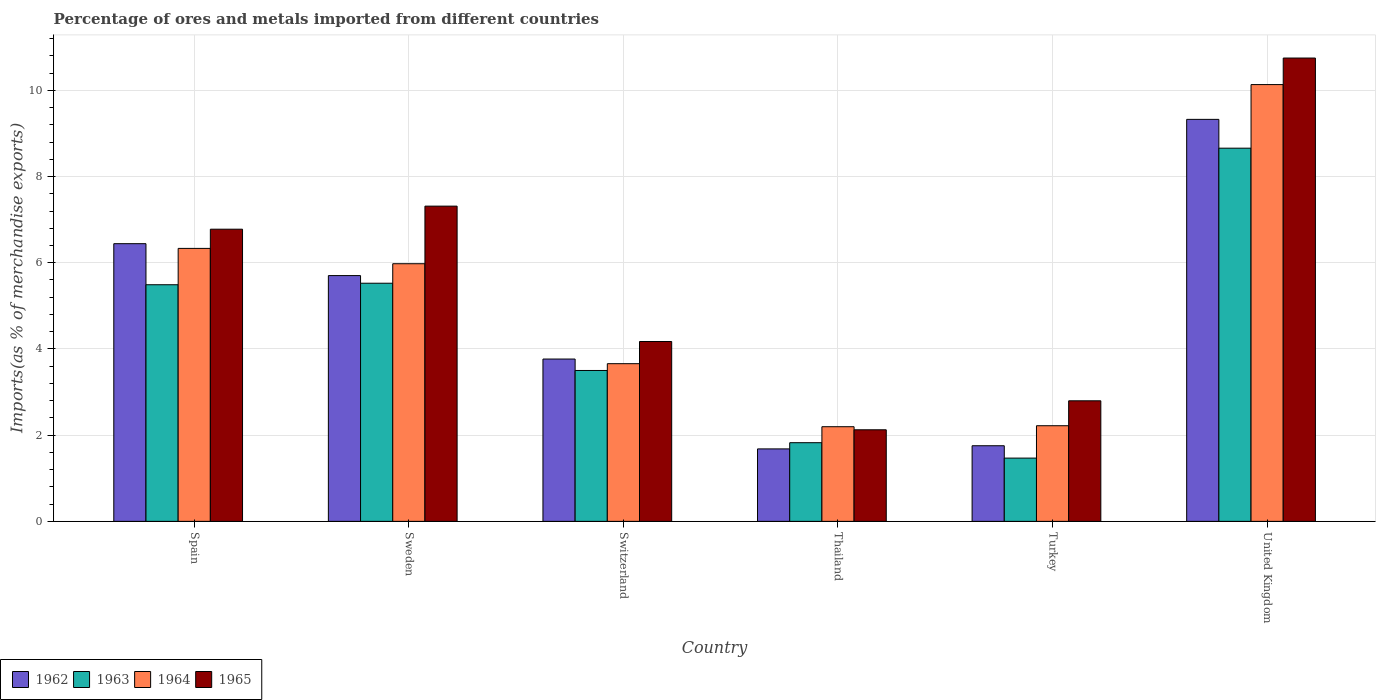How many different coloured bars are there?
Ensure brevity in your answer.  4. Are the number of bars per tick equal to the number of legend labels?
Give a very brief answer. Yes. Are the number of bars on each tick of the X-axis equal?
Your answer should be very brief. Yes. In how many cases, is the number of bars for a given country not equal to the number of legend labels?
Your answer should be compact. 0. What is the percentage of imports to different countries in 1962 in Spain?
Provide a succinct answer. 6.44. Across all countries, what is the maximum percentage of imports to different countries in 1962?
Your answer should be compact. 9.33. Across all countries, what is the minimum percentage of imports to different countries in 1965?
Provide a short and direct response. 2.12. In which country was the percentage of imports to different countries in 1962 minimum?
Your answer should be compact. Thailand. What is the total percentage of imports to different countries in 1964 in the graph?
Make the answer very short. 30.52. What is the difference between the percentage of imports to different countries in 1965 in Spain and that in Turkey?
Offer a terse response. 3.98. What is the difference between the percentage of imports to different countries in 1962 in Sweden and the percentage of imports to different countries in 1964 in Spain?
Offer a very short reply. -0.63. What is the average percentage of imports to different countries in 1964 per country?
Ensure brevity in your answer.  5.09. What is the difference between the percentage of imports to different countries of/in 1963 and percentage of imports to different countries of/in 1964 in Switzerland?
Offer a very short reply. -0.16. What is the ratio of the percentage of imports to different countries in 1962 in Sweden to that in United Kingdom?
Give a very brief answer. 0.61. Is the percentage of imports to different countries in 1965 in Sweden less than that in United Kingdom?
Offer a terse response. Yes. What is the difference between the highest and the second highest percentage of imports to different countries in 1963?
Your response must be concise. 3.17. What is the difference between the highest and the lowest percentage of imports to different countries in 1965?
Keep it short and to the point. 8.62. In how many countries, is the percentage of imports to different countries in 1963 greater than the average percentage of imports to different countries in 1963 taken over all countries?
Keep it short and to the point. 3. Is the sum of the percentage of imports to different countries in 1963 in Sweden and United Kingdom greater than the maximum percentage of imports to different countries in 1965 across all countries?
Your answer should be very brief. Yes. What does the 4th bar from the left in Thailand represents?
Keep it short and to the point. 1965. What does the 2nd bar from the right in Thailand represents?
Offer a terse response. 1964. How many bars are there?
Make the answer very short. 24. Are all the bars in the graph horizontal?
Your answer should be very brief. No. How many countries are there in the graph?
Your answer should be very brief. 6. Are the values on the major ticks of Y-axis written in scientific E-notation?
Make the answer very short. No. Where does the legend appear in the graph?
Provide a short and direct response. Bottom left. What is the title of the graph?
Offer a terse response. Percentage of ores and metals imported from different countries. Does "1977" appear as one of the legend labels in the graph?
Provide a short and direct response. No. What is the label or title of the Y-axis?
Your answer should be compact. Imports(as % of merchandise exports). What is the Imports(as % of merchandise exports) of 1962 in Spain?
Offer a very short reply. 6.44. What is the Imports(as % of merchandise exports) of 1963 in Spain?
Give a very brief answer. 5.49. What is the Imports(as % of merchandise exports) of 1964 in Spain?
Your answer should be compact. 6.33. What is the Imports(as % of merchandise exports) in 1965 in Spain?
Provide a short and direct response. 6.78. What is the Imports(as % of merchandise exports) of 1962 in Sweden?
Keep it short and to the point. 5.7. What is the Imports(as % of merchandise exports) in 1963 in Sweden?
Ensure brevity in your answer.  5.52. What is the Imports(as % of merchandise exports) in 1964 in Sweden?
Your answer should be very brief. 5.98. What is the Imports(as % of merchandise exports) of 1965 in Sweden?
Provide a short and direct response. 7.31. What is the Imports(as % of merchandise exports) in 1962 in Switzerland?
Your answer should be very brief. 3.77. What is the Imports(as % of merchandise exports) in 1963 in Switzerland?
Your answer should be very brief. 3.5. What is the Imports(as % of merchandise exports) of 1964 in Switzerland?
Keep it short and to the point. 3.66. What is the Imports(as % of merchandise exports) in 1965 in Switzerland?
Provide a short and direct response. 4.17. What is the Imports(as % of merchandise exports) of 1962 in Thailand?
Ensure brevity in your answer.  1.68. What is the Imports(as % of merchandise exports) of 1963 in Thailand?
Offer a terse response. 1.83. What is the Imports(as % of merchandise exports) in 1964 in Thailand?
Your answer should be compact. 2.2. What is the Imports(as % of merchandise exports) of 1965 in Thailand?
Make the answer very short. 2.12. What is the Imports(as % of merchandise exports) in 1962 in Turkey?
Offer a terse response. 1.75. What is the Imports(as % of merchandise exports) of 1963 in Turkey?
Ensure brevity in your answer.  1.47. What is the Imports(as % of merchandise exports) in 1964 in Turkey?
Provide a short and direct response. 2.22. What is the Imports(as % of merchandise exports) of 1965 in Turkey?
Provide a succinct answer. 2.8. What is the Imports(as % of merchandise exports) of 1962 in United Kingdom?
Make the answer very short. 9.33. What is the Imports(as % of merchandise exports) in 1963 in United Kingdom?
Keep it short and to the point. 8.66. What is the Imports(as % of merchandise exports) in 1964 in United Kingdom?
Your answer should be compact. 10.13. What is the Imports(as % of merchandise exports) in 1965 in United Kingdom?
Your answer should be very brief. 10.75. Across all countries, what is the maximum Imports(as % of merchandise exports) of 1962?
Make the answer very short. 9.33. Across all countries, what is the maximum Imports(as % of merchandise exports) of 1963?
Provide a succinct answer. 8.66. Across all countries, what is the maximum Imports(as % of merchandise exports) of 1964?
Your response must be concise. 10.13. Across all countries, what is the maximum Imports(as % of merchandise exports) in 1965?
Offer a very short reply. 10.75. Across all countries, what is the minimum Imports(as % of merchandise exports) in 1962?
Your answer should be very brief. 1.68. Across all countries, what is the minimum Imports(as % of merchandise exports) of 1963?
Offer a very short reply. 1.47. Across all countries, what is the minimum Imports(as % of merchandise exports) in 1964?
Provide a succinct answer. 2.2. Across all countries, what is the minimum Imports(as % of merchandise exports) in 1965?
Keep it short and to the point. 2.12. What is the total Imports(as % of merchandise exports) of 1962 in the graph?
Provide a succinct answer. 28.67. What is the total Imports(as % of merchandise exports) in 1963 in the graph?
Offer a terse response. 26.47. What is the total Imports(as % of merchandise exports) of 1964 in the graph?
Offer a terse response. 30.52. What is the total Imports(as % of merchandise exports) of 1965 in the graph?
Ensure brevity in your answer.  33.94. What is the difference between the Imports(as % of merchandise exports) in 1962 in Spain and that in Sweden?
Give a very brief answer. 0.74. What is the difference between the Imports(as % of merchandise exports) of 1963 in Spain and that in Sweden?
Your answer should be compact. -0.04. What is the difference between the Imports(as % of merchandise exports) of 1964 in Spain and that in Sweden?
Ensure brevity in your answer.  0.36. What is the difference between the Imports(as % of merchandise exports) in 1965 in Spain and that in Sweden?
Ensure brevity in your answer.  -0.54. What is the difference between the Imports(as % of merchandise exports) of 1962 in Spain and that in Switzerland?
Offer a very short reply. 2.68. What is the difference between the Imports(as % of merchandise exports) of 1963 in Spain and that in Switzerland?
Your response must be concise. 1.99. What is the difference between the Imports(as % of merchandise exports) in 1964 in Spain and that in Switzerland?
Your answer should be very brief. 2.67. What is the difference between the Imports(as % of merchandise exports) of 1965 in Spain and that in Switzerland?
Make the answer very short. 2.61. What is the difference between the Imports(as % of merchandise exports) of 1962 in Spain and that in Thailand?
Ensure brevity in your answer.  4.76. What is the difference between the Imports(as % of merchandise exports) of 1963 in Spain and that in Thailand?
Keep it short and to the point. 3.66. What is the difference between the Imports(as % of merchandise exports) in 1964 in Spain and that in Thailand?
Your answer should be very brief. 4.14. What is the difference between the Imports(as % of merchandise exports) in 1965 in Spain and that in Thailand?
Ensure brevity in your answer.  4.65. What is the difference between the Imports(as % of merchandise exports) in 1962 in Spain and that in Turkey?
Your answer should be very brief. 4.69. What is the difference between the Imports(as % of merchandise exports) in 1963 in Spain and that in Turkey?
Keep it short and to the point. 4.02. What is the difference between the Imports(as % of merchandise exports) in 1964 in Spain and that in Turkey?
Keep it short and to the point. 4.11. What is the difference between the Imports(as % of merchandise exports) of 1965 in Spain and that in Turkey?
Your answer should be compact. 3.98. What is the difference between the Imports(as % of merchandise exports) in 1962 in Spain and that in United Kingdom?
Give a very brief answer. -2.88. What is the difference between the Imports(as % of merchandise exports) of 1963 in Spain and that in United Kingdom?
Provide a succinct answer. -3.17. What is the difference between the Imports(as % of merchandise exports) of 1964 in Spain and that in United Kingdom?
Your response must be concise. -3.8. What is the difference between the Imports(as % of merchandise exports) in 1965 in Spain and that in United Kingdom?
Give a very brief answer. -3.97. What is the difference between the Imports(as % of merchandise exports) of 1962 in Sweden and that in Switzerland?
Offer a very short reply. 1.94. What is the difference between the Imports(as % of merchandise exports) in 1963 in Sweden and that in Switzerland?
Keep it short and to the point. 2.02. What is the difference between the Imports(as % of merchandise exports) of 1964 in Sweden and that in Switzerland?
Offer a terse response. 2.32. What is the difference between the Imports(as % of merchandise exports) in 1965 in Sweden and that in Switzerland?
Offer a very short reply. 3.14. What is the difference between the Imports(as % of merchandise exports) of 1962 in Sweden and that in Thailand?
Your response must be concise. 4.02. What is the difference between the Imports(as % of merchandise exports) in 1963 in Sweden and that in Thailand?
Provide a succinct answer. 3.7. What is the difference between the Imports(as % of merchandise exports) in 1964 in Sweden and that in Thailand?
Offer a very short reply. 3.78. What is the difference between the Imports(as % of merchandise exports) of 1965 in Sweden and that in Thailand?
Give a very brief answer. 5.19. What is the difference between the Imports(as % of merchandise exports) of 1962 in Sweden and that in Turkey?
Keep it short and to the point. 3.95. What is the difference between the Imports(as % of merchandise exports) of 1963 in Sweden and that in Turkey?
Your answer should be compact. 4.06. What is the difference between the Imports(as % of merchandise exports) of 1964 in Sweden and that in Turkey?
Make the answer very short. 3.76. What is the difference between the Imports(as % of merchandise exports) of 1965 in Sweden and that in Turkey?
Your answer should be very brief. 4.52. What is the difference between the Imports(as % of merchandise exports) in 1962 in Sweden and that in United Kingdom?
Your answer should be compact. -3.62. What is the difference between the Imports(as % of merchandise exports) of 1963 in Sweden and that in United Kingdom?
Give a very brief answer. -3.13. What is the difference between the Imports(as % of merchandise exports) of 1964 in Sweden and that in United Kingdom?
Your answer should be compact. -4.16. What is the difference between the Imports(as % of merchandise exports) in 1965 in Sweden and that in United Kingdom?
Your response must be concise. -3.44. What is the difference between the Imports(as % of merchandise exports) in 1962 in Switzerland and that in Thailand?
Make the answer very short. 2.08. What is the difference between the Imports(as % of merchandise exports) in 1963 in Switzerland and that in Thailand?
Ensure brevity in your answer.  1.68. What is the difference between the Imports(as % of merchandise exports) in 1964 in Switzerland and that in Thailand?
Offer a very short reply. 1.46. What is the difference between the Imports(as % of merchandise exports) of 1965 in Switzerland and that in Thailand?
Give a very brief answer. 2.05. What is the difference between the Imports(as % of merchandise exports) of 1962 in Switzerland and that in Turkey?
Keep it short and to the point. 2.01. What is the difference between the Imports(as % of merchandise exports) of 1963 in Switzerland and that in Turkey?
Offer a very short reply. 2.03. What is the difference between the Imports(as % of merchandise exports) in 1964 in Switzerland and that in Turkey?
Provide a short and direct response. 1.44. What is the difference between the Imports(as % of merchandise exports) of 1965 in Switzerland and that in Turkey?
Provide a short and direct response. 1.38. What is the difference between the Imports(as % of merchandise exports) of 1962 in Switzerland and that in United Kingdom?
Keep it short and to the point. -5.56. What is the difference between the Imports(as % of merchandise exports) of 1963 in Switzerland and that in United Kingdom?
Ensure brevity in your answer.  -5.16. What is the difference between the Imports(as % of merchandise exports) of 1964 in Switzerland and that in United Kingdom?
Keep it short and to the point. -6.48. What is the difference between the Imports(as % of merchandise exports) of 1965 in Switzerland and that in United Kingdom?
Your answer should be very brief. -6.58. What is the difference between the Imports(as % of merchandise exports) in 1962 in Thailand and that in Turkey?
Offer a terse response. -0.07. What is the difference between the Imports(as % of merchandise exports) of 1963 in Thailand and that in Turkey?
Give a very brief answer. 0.36. What is the difference between the Imports(as % of merchandise exports) in 1964 in Thailand and that in Turkey?
Give a very brief answer. -0.02. What is the difference between the Imports(as % of merchandise exports) of 1965 in Thailand and that in Turkey?
Your response must be concise. -0.67. What is the difference between the Imports(as % of merchandise exports) of 1962 in Thailand and that in United Kingdom?
Keep it short and to the point. -7.65. What is the difference between the Imports(as % of merchandise exports) of 1963 in Thailand and that in United Kingdom?
Your response must be concise. -6.83. What is the difference between the Imports(as % of merchandise exports) in 1964 in Thailand and that in United Kingdom?
Offer a terse response. -7.94. What is the difference between the Imports(as % of merchandise exports) in 1965 in Thailand and that in United Kingdom?
Offer a terse response. -8.62. What is the difference between the Imports(as % of merchandise exports) in 1962 in Turkey and that in United Kingdom?
Your response must be concise. -7.57. What is the difference between the Imports(as % of merchandise exports) in 1963 in Turkey and that in United Kingdom?
Keep it short and to the point. -7.19. What is the difference between the Imports(as % of merchandise exports) of 1964 in Turkey and that in United Kingdom?
Your answer should be very brief. -7.91. What is the difference between the Imports(as % of merchandise exports) of 1965 in Turkey and that in United Kingdom?
Your answer should be very brief. -7.95. What is the difference between the Imports(as % of merchandise exports) of 1962 in Spain and the Imports(as % of merchandise exports) of 1963 in Sweden?
Give a very brief answer. 0.92. What is the difference between the Imports(as % of merchandise exports) in 1962 in Spain and the Imports(as % of merchandise exports) in 1964 in Sweden?
Your answer should be compact. 0.47. What is the difference between the Imports(as % of merchandise exports) in 1962 in Spain and the Imports(as % of merchandise exports) in 1965 in Sweden?
Your answer should be very brief. -0.87. What is the difference between the Imports(as % of merchandise exports) of 1963 in Spain and the Imports(as % of merchandise exports) of 1964 in Sweden?
Your answer should be compact. -0.49. What is the difference between the Imports(as % of merchandise exports) in 1963 in Spain and the Imports(as % of merchandise exports) in 1965 in Sweden?
Offer a terse response. -1.82. What is the difference between the Imports(as % of merchandise exports) in 1964 in Spain and the Imports(as % of merchandise exports) in 1965 in Sweden?
Ensure brevity in your answer.  -0.98. What is the difference between the Imports(as % of merchandise exports) of 1962 in Spain and the Imports(as % of merchandise exports) of 1963 in Switzerland?
Provide a succinct answer. 2.94. What is the difference between the Imports(as % of merchandise exports) of 1962 in Spain and the Imports(as % of merchandise exports) of 1964 in Switzerland?
Ensure brevity in your answer.  2.78. What is the difference between the Imports(as % of merchandise exports) of 1962 in Spain and the Imports(as % of merchandise exports) of 1965 in Switzerland?
Your response must be concise. 2.27. What is the difference between the Imports(as % of merchandise exports) in 1963 in Spain and the Imports(as % of merchandise exports) in 1964 in Switzerland?
Your answer should be very brief. 1.83. What is the difference between the Imports(as % of merchandise exports) of 1963 in Spain and the Imports(as % of merchandise exports) of 1965 in Switzerland?
Keep it short and to the point. 1.32. What is the difference between the Imports(as % of merchandise exports) of 1964 in Spain and the Imports(as % of merchandise exports) of 1965 in Switzerland?
Provide a short and direct response. 2.16. What is the difference between the Imports(as % of merchandise exports) of 1962 in Spain and the Imports(as % of merchandise exports) of 1963 in Thailand?
Provide a succinct answer. 4.62. What is the difference between the Imports(as % of merchandise exports) of 1962 in Spain and the Imports(as % of merchandise exports) of 1964 in Thailand?
Your answer should be compact. 4.25. What is the difference between the Imports(as % of merchandise exports) in 1962 in Spain and the Imports(as % of merchandise exports) in 1965 in Thailand?
Provide a succinct answer. 4.32. What is the difference between the Imports(as % of merchandise exports) in 1963 in Spain and the Imports(as % of merchandise exports) in 1964 in Thailand?
Your response must be concise. 3.29. What is the difference between the Imports(as % of merchandise exports) of 1963 in Spain and the Imports(as % of merchandise exports) of 1965 in Thailand?
Give a very brief answer. 3.37. What is the difference between the Imports(as % of merchandise exports) of 1964 in Spain and the Imports(as % of merchandise exports) of 1965 in Thailand?
Make the answer very short. 4.21. What is the difference between the Imports(as % of merchandise exports) in 1962 in Spain and the Imports(as % of merchandise exports) in 1963 in Turkey?
Provide a short and direct response. 4.97. What is the difference between the Imports(as % of merchandise exports) of 1962 in Spain and the Imports(as % of merchandise exports) of 1964 in Turkey?
Provide a short and direct response. 4.22. What is the difference between the Imports(as % of merchandise exports) in 1962 in Spain and the Imports(as % of merchandise exports) in 1965 in Turkey?
Ensure brevity in your answer.  3.65. What is the difference between the Imports(as % of merchandise exports) of 1963 in Spain and the Imports(as % of merchandise exports) of 1964 in Turkey?
Provide a short and direct response. 3.27. What is the difference between the Imports(as % of merchandise exports) in 1963 in Spain and the Imports(as % of merchandise exports) in 1965 in Turkey?
Provide a short and direct response. 2.69. What is the difference between the Imports(as % of merchandise exports) in 1964 in Spain and the Imports(as % of merchandise exports) in 1965 in Turkey?
Keep it short and to the point. 3.54. What is the difference between the Imports(as % of merchandise exports) of 1962 in Spain and the Imports(as % of merchandise exports) of 1963 in United Kingdom?
Your answer should be compact. -2.22. What is the difference between the Imports(as % of merchandise exports) in 1962 in Spain and the Imports(as % of merchandise exports) in 1964 in United Kingdom?
Your answer should be very brief. -3.69. What is the difference between the Imports(as % of merchandise exports) of 1962 in Spain and the Imports(as % of merchandise exports) of 1965 in United Kingdom?
Your response must be concise. -4.31. What is the difference between the Imports(as % of merchandise exports) in 1963 in Spain and the Imports(as % of merchandise exports) in 1964 in United Kingdom?
Your response must be concise. -4.64. What is the difference between the Imports(as % of merchandise exports) of 1963 in Spain and the Imports(as % of merchandise exports) of 1965 in United Kingdom?
Provide a succinct answer. -5.26. What is the difference between the Imports(as % of merchandise exports) in 1964 in Spain and the Imports(as % of merchandise exports) in 1965 in United Kingdom?
Keep it short and to the point. -4.42. What is the difference between the Imports(as % of merchandise exports) of 1962 in Sweden and the Imports(as % of merchandise exports) of 1963 in Switzerland?
Give a very brief answer. 2.2. What is the difference between the Imports(as % of merchandise exports) in 1962 in Sweden and the Imports(as % of merchandise exports) in 1964 in Switzerland?
Your response must be concise. 2.04. What is the difference between the Imports(as % of merchandise exports) of 1962 in Sweden and the Imports(as % of merchandise exports) of 1965 in Switzerland?
Make the answer very short. 1.53. What is the difference between the Imports(as % of merchandise exports) of 1963 in Sweden and the Imports(as % of merchandise exports) of 1964 in Switzerland?
Your answer should be compact. 1.87. What is the difference between the Imports(as % of merchandise exports) in 1963 in Sweden and the Imports(as % of merchandise exports) in 1965 in Switzerland?
Offer a very short reply. 1.35. What is the difference between the Imports(as % of merchandise exports) in 1964 in Sweden and the Imports(as % of merchandise exports) in 1965 in Switzerland?
Offer a very short reply. 1.8. What is the difference between the Imports(as % of merchandise exports) of 1962 in Sweden and the Imports(as % of merchandise exports) of 1963 in Thailand?
Ensure brevity in your answer.  3.88. What is the difference between the Imports(as % of merchandise exports) of 1962 in Sweden and the Imports(as % of merchandise exports) of 1964 in Thailand?
Your answer should be very brief. 3.51. What is the difference between the Imports(as % of merchandise exports) of 1962 in Sweden and the Imports(as % of merchandise exports) of 1965 in Thailand?
Provide a succinct answer. 3.58. What is the difference between the Imports(as % of merchandise exports) in 1963 in Sweden and the Imports(as % of merchandise exports) in 1964 in Thailand?
Provide a succinct answer. 3.33. What is the difference between the Imports(as % of merchandise exports) in 1963 in Sweden and the Imports(as % of merchandise exports) in 1965 in Thailand?
Provide a succinct answer. 3.4. What is the difference between the Imports(as % of merchandise exports) in 1964 in Sweden and the Imports(as % of merchandise exports) in 1965 in Thailand?
Give a very brief answer. 3.85. What is the difference between the Imports(as % of merchandise exports) of 1962 in Sweden and the Imports(as % of merchandise exports) of 1963 in Turkey?
Your answer should be very brief. 4.23. What is the difference between the Imports(as % of merchandise exports) in 1962 in Sweden and the Imports(as % of merchandise exports) in 1964 in Turkey?
Give a very brief answer. 3.48. What is the difference between the Imports(as % of merchandise exports) in 1962 in Sweden and the Imports(as % of merchandise exports) in 1965 in Turkey?
Provide a short and direct response. 2.9. What is the difference between the Imports(as % of merchandise exports) of 1963 in Sweden and the Imports(as % of merchandise exports) of 1964 in Turkey?
Offer a very short reply. 3.31. What is the difference between the Imports(as % of merchandise exports) in 1963 in Sweden and the Imports(as % of merchandise exports) in 1965 in Turkey?
Your answer should be very brief. 2.73. What is the difference between the Imports(as % of merchandise exports) of 1964 in Sweden and the Imports(as % of merchandise exports) of 1965 in Turkey?
Your answer should be very brief. 3.18. What is the difference between the Imports(as % of merchandise exports) in 1962 in Sweden and the Imports(as % of merchandise exports) in 1963 in United Kingdom?
Keep it short and to the point. -2.96. What is the difference between the Imports(as % of merchandise exports) in 1962 in Sweden and the Imports(as % of merchandise exports) in 1964 in United Kingdom?
Make the answer very short. -4.43. What is the difference between the Imports(as % of merchandise exports) in 1962 in Sweden and the Imports(as % of merchandise exports) in 1965 in United Kingdom?
Provide a succinct answer. -5.05. What is the difference between the Imports(as % of merchandise exports) in 1963 in Sweden and the Imports(as % of merchandise exports) in 1964 in United Kingdom?
Your answer should be very brief. -4.61. What is the difference between the Imports(as % of merchandise exports) of 1963 in Sweden and the Imports(as % of merchandise exports) of 1965 in United Kingdom?
Give a very brief answer. -5.22. What is the difference between the Imports(as % of merchandise exports) of 1964 in Sweden and the Imports(as % of merchandise exports) of 1965 in United Kingdom?
Offer a very short reply. -4.77. What is the difference between the Imports(as % of merchandise exports) in 1962 in Switzerland and the Imports(as % of merchandise exports) in 1963 in Thailand?
Keep it short and to the point. 1.94. What is the difference between the Imports(as % of merchandise exports) in 1962 in Switzerland and the Imports(as % of merchandise exports) in 1964 in Thailand?
Offer a very short reply. 1.57. What is the difference between the Imports(as % of merchandise exports) in 1962 in Switzerland and the Imports(as % of merchandise exports) in 1965 in Thailand?
Provide a succinct answer. 1.64. What is the difference between the Imports(as % of merchandise exports) of 1963 in Switzerland and the Imports(as % of merchandise exports) of 1964 in Thailand?
Offer a very short reply. 1.3. What is the difference between the Imports(as % of merchandise exports) in 1963 in Switzerland and the Imports(as % of merchandise exports) in 1965 in Thailand?
Your answer should be very brief. 1.38. What is the difference between the Imports(as % of merchandise exports) in 1964 in Switzerland and the Imports(as % of merchandise exports) in 1965 in Thailand?
Provide a succinct answer. 1.53. What is the difference between the Imports(as % of merchandise exports) of 1962 in Switzerland and the Imports(as % of merchandise exports) of 1963 in Turkey?
Ensure brevity in your answer.  2.3. What is the difference between the Imports(as % of merchandise exports) in 1962 in Switzerland and the Imports(as % of merchandise exports) in 1964 in Turkey?
Make the answer very short. 1.55. What is the difference between the Imports(as % of merchandise exports) in 1962 in Switzerland and the Imports(as % of merchandise exports) in 1965 in Turkey?
Provide a succinct answer. 0.97. What is the difference between the Imports(as % of merchandise exports) in 1963 in Switzerland and the Imports(as % of merchandise exports) in 1964 in Turkey?
Your answer should be compact. 1.28. What is the difference between the Imports(as % of merchandise exports) of 1963 in Switzerland and the Imports(as % of merchandise exports) of 1965 in Turkey?
Provide a short and direct response. 0.7. What is the difference between the Imports(as % of merchandise exports) in 1964 in Switzerland and the Imports(as % of merchandise exports) in 1965 in Turkey?
Offer a very short reply. 0.86. What is the difference between the Imports(as % of merchandise exports) in 1962 in Switzerland and the Imports(as % of merchandise exports) in 1963 in United Kingdom?
Give a very brief answer. -4.89. What is the difference between the Imports(as % of merchandise exports) of 1962 in Switzerland and the Imports(as % of merchandise exports) of 1964 in United Kingdom?
Your answer should be very brief. -6.37. What is the difference between the Imports(as % of merchandise exports) of 1962 in Switzerland and the Imports(as % of merchandise exports) of 1965 in United Kingdom?
Offer a very short reply. -6.98. What is the difference between the Imports(as % of merchandise exports) of 1963 in Switzerland and the Imports(as % of merchandise exports) of 1964 in United Kingdom?
Offer a very short reply. -6.63. What is the difference between the Imports(as % of merchandise exports) of 1963 in Switzerland and the Imports(as % of merchandise exports) of 1965 in United Kingdom?
Offer a terse response. -7.25. What is the difference between the Imports(as % of merchandise exports) of 1964 in Switzerland and the Imports(as % of merchandise exports) of 1965 in United Kingdom?
Ensure brevity in your answer.  -7.09. What is the difference between the Imports(as % of merchandise exports) in 1962 in Thailand and the Imports(as % of merchandise exports) in 1963 in Turkey?
Provide a short and direct response. 0.21. What is the difference between the Imports(as % of merchandise exports) in 1962 in Thailand and the Imports(as % of merchandise exports) in 1964 in Turkey?
Provide a short and direct response. -0.54. What is the difference between the Imports(as % of merchandise exports) in 1962 in Thailand and the Imports(as % of merchandise exports) in 1965 in Turkey?
Ensure brevity in your answer.  -1.12. What is the difference between the Imports(as % of merchandise exports) of 1963 in Thailand and the Imports(as % of merchandise exports) of 1964 in Turkey?
Provide a succinct answer. -0.39. What is the difference between the Imports(as % of merchandise exports) of 1963 in Thailand and the Imports(as % of merchandise exports) of 1965 in Turkey?
Your response must be concise. -0.97. What is the difference between the Imports(as % of merchandise exports) in 1964 in Thailand and the Imports(as % of merchandise exports) in 1965 in Turkey?
Your answer should be very brief. -0.6. What is the difference between the Imports(as % of merchandise exports) of 1962 in Thailand and the Imports(as % of merchandise exports) of 1963 in United Kingdom?
Your answer should be compact. -6.98. What is the difference between the Imports(as % of merchandise exports) of 1962 in Thailand and the Imports(as % of merchandise exports) of 1964 in United Kingdom?
Keep it short and to the point. -8.45. What is the difference between the Imports(as % of merchandise exports) of 1962 in Thailand and the Imports(as % of merchandise exports) of 1965 in United Kingdom?
Your answer should be very brief. -9.07. What is the difference between the Imports(as % of merchandise exports) of 1963 in Thailand and the Imports(as % of merchandise exports) of 1964 in United Kingdom?
Your answer should be very brief. -8.31. What is the difference between the Imports(as % of merchandise exports) of 1963 in Thailand and the Imports(as % of merchandise exports) of 1965 in United Kingdom?
Make the answer very short. -8.92. What is the difference between the Imports(as % of merchandise exports) of 1964 in Thailand and the Imports(as % of merchandise exports) of 1965 in United Kingdom?
Your response must be concise. -8.55. What is the difference between the Imports(as % of merchandise exports) of 1962 in Turkey and the Imports(as % of merchandise exports) of 1963 in United Kingdom?
Keep it short and to the point. -6.9. What is the difference between the Imports(as % of merchandise exports) of 1962 in Turkey and the Imports(as % of merchandise exports) of 1964 in United Kingdom?
Your answer should be very brief. -8.38. What is the difference between the Imports(as % of merchandise exports) of 1962 in Turkey and the Imports(as % of merchandise exports) of 1965 in United Kingdom?
Your answer should be very brief. -8.99. What is the difference between the Imports(as % of merchandise exports) in 1963 in Turkey and the Imports(as % of merchandise exports) in 1964 in United Kingdom?
Offer a very short reply. -8.67. What is the difference between the Imports(as % of merchandise exports) in 1963 in Turkey and the Imports(as % of merchandise exports) in 1965 in United Kingdom?
Your response must be concise. -9.28. What is the difference between the Imports(as % of merchandise exports) in 1964 in Turkey and the Imports(as % of merchandise exports) in 1965 in United Kingdom?
Your answer should be very brief. -8.53. What is the average Imports(as % of merchandise exports) of 1962 per country?
Keep it short and to the point. 4.78. What is the average Imports(as % of merchandise exports) of 1963 per country?
Provide a succinct answer. 4.41. What is the average Imports(as % of merchandise exports) in 1964 per country?
Offer a terse response. 5.09. What is the average Imports(as % of merchandise exports) in 1965 per country?
Make the answer very short. 5.66. What is the difference between the Imports(as % of merchandise exports) in 1962 and Imports(as % of merchandise exports) in 1963 in Spain?
Offer a terse response. 0.95. What is the difference between the Imports(as % of merchandise exports) in 1962 and Imports(as % of merchandise exports) in 1964 in Spain?
Give a very brief answer. 0.11. What is the difference between the Imports(as % of merchandise exports) in 1962 and Imports(as % of merchandise exports) in 1965 in Spain?
Make the answer very short. -0.34. What is the difference between the Imports(as % of merchandise exports) in 1963 and Imports(as % of merchandise exports) in 1964 in Spain?
Offer a terse response. -0.84. What is the difference between the Imports(as % of merchandise exports) of 1963 and Imports(as % of merchandise exports) of 1965 in Spain?
Keep it short and to the point. -1.29. What is the difference between the Imports(as % of merchandise exports) of 1964 and Imports(as % of merchandise exports) of 1965 in Spain?
Make the answer very short. -0.45. What is the difference between the Imports(as % of merchandise exports) of 1962 and Imports(as % of merchandise exports) of 1963 in Sweden?
Give a very brief answer. 0.18. What is the difference between the Imports(as % of merchandise exports) of 1962 and Imports(as % of merchandise exports) of 1964 in Sweden?
Keep it short and to the point. -0.28. What is the difference between the Imports(as % of merchandise exports) in 1962 and Imports(as % of merchandise exports) in 1965 in Sweden?
Your answer should be very brief. -1.61. What is the difference between the Imports(as % of merchandise exports) of 1963 and Imports(as % of merchandise exports) of 1964 in Sweden?
Offer a very short reply. -0.45. What is the difference between the Imports(as % of merchandise exports) of 1963 and Imports(as % of merchandise exports) of 1965 in Sweden?
Your response must be concise. -1.79. What is the difference between the Imports(as % of merchandise exports) of 1964 and Imports(as % of merchandise exports) of 1965 in Sweden?
Provide a short and direct response. -1.34. What is the difference between the Imports(as % of merchandise exports) in 1962 and Imports(as % of merchandise exports) in 1963 in Switzerland?
Provide a short and direct response. 0.27. What is the difference between the Imports(as % of merchandise exports) of 1962 and Imports(as % of merchandise exports) of 1964 in Switzerland?
Offer a very short reply. 0.11. What is the difference between the Imports(as % of merchandise exports) of 1962 and Imports(as % of merchandise exports) of 1965 in Switzerland?
Your answer should be compact. -0.41. What is the difference between the Imports(as % of merchandise exports) in 1963 and Imports(as % of merchandise exports) in 1964 in Switzerland?
Ensure brevity in your answer.  -0.16. What is the difference between the Imports(as % of merchandise exports) in 1963 and Imports(as % of merchandise exports) in 1965 in Switzerland?
Your response must be concise. -0.67. What is the difference between the Imports(as % of merchandise exports) of 1964 and Imports(as % of merchandise exports) of 1965 in Switzerland?
Your response must be concise. -0.51. What is the difference between the Imports(as % of merchandise exports) of 1962 and Imports(as % of merchandise exports) of 1963 in Thailand?
Your answer should be very brief. -0.14. What is the difference between the Imports(as % of merchandise exports) in 1962 and Imports(as % of merchandise exports) in 1964 in Thailand?
Your answer should be compact. -0.51. What is the difference between the Imports(as % of merchandise exports) of 1962 and Imports(as % of merchandise exports) of 1965 in Thailand?
Give a very brief answer. -0.44. What is the difference between the Imports(as % of merchandise exports) in 1963 and Imports(as % of merchandise exports) in 1964 in Thailand?
Offer a terse response. -0.37. What is the difference between the Imports(as % of merchandise exports) of 1963 and Imports(as % of merchandise exports) of 1965 in Thailand?
Your answer should be very brief. -0.3. What is the difference between the Imports(as % of merchandise exports) of 1964 and Imports(as % of merchandise exports) of 1965 in Thailand?
Provide a short and direct response. 0.07. What is the difference between the Imports(as % of merchandise exports) in 1962 and Imports(as % of merchandise exports) in 1963 in Turkey?
Offer a very short reply. 0.29. What is the difference between the Imports(as % of merchandise exports) of 1962 and Imports(as % of merchandise exports) of 1964 in Turkey?
Ensure brevity in your answer.  -0.46. What is the difference between the Imports(as % of merchandise exports) of 1962 and Imports(as % of merchandise exports) of 1965 in Turkey?
Your response must be concise. -1.04. What is the difference between the Imports(as % of merchandise exports) in 1963 and Imports(as % of merchandise exports) in 1964 in Turkey?
Provide a succinct answer. -0.75. What is the difference between the Imports(as % of merchandise exports) in 1963 and Imports(as % of merchandise exports) in 1965 in Turkey?
Give a very brief answer. -1.33. What is the difference between the Imports(as % of merchandise exports) in 1964 and Imports(as % of merchandise exports) in 1965 in Turkey?
Offer a terse response. -0.58. What is the difference between the Imports(as % of merchandise exports) in 1962 and Imports(as % of merchandise exports) in 1963 in United Kingdom?
Your answer should be very brief. 0.67. What is the difference between the Imports(as % of merchandise exports) in 1962 and Imports(as % of merchandise exports) in 1964 in United Kingdom?
Offer a terse response. -0.81. What is the difference between the Imports(as % of merchandise exports) in 1962 and Imports(as % of merchandise exports) in 1965 in United Kingdom?
Offer a very short reply. -1.42. What is the difference between the Imports(as % of merchandise exports) of 1963 and Imports(as % of merchandise exports) of 1964 in United Kingdom?
Make the answer very short. -1.48. What is the difference between the Imports(as % of merchandise exports) of 1963 and Imports(as % of merchandise exports) of 1965 in United Kingdom?
Your answer should be very brief. -2.09. What is the difference between the Imports(as % of merchandise exports) in 1964 and Imports(as % of merchandise exports) in 1965 in United Kingdom?
Your answer should be compact. -0.62. What is the ratio of the Imports(as % of merchandise exports) of 1962 in Spain to that in Sweden?
Your answer should be very brief. 1.13. What is the ratio of the Imports(as % of merchandise exports) of 1963 in Spain to that in Sweden?
Provide a succinct answer. 0.99. What is the ratio of the Imports(as % of merchandise exports) in 1964 in Spain to that in Sweden?
Offer a very short reply. 1.06. What is the ratio of the Imports(as % of merchandise exports) of 1965 in Spain to that in Sweden?
Your answer should be very brief. 0.93. What is the ratio of the Imports(as % of merchandise exports) of 1962 in Spain to that in Switzerland?
Keep it short and to the point. 1.71. What is the ratio of the Imports(as % of merchandise exports) of 1963 in Spain to that in Switzerland?
Ensure brevity in your answer.  1.57. What is the ratio of the Imports(as % of merchandise exports) in 1964 in Spain to that in Switzerland?
Your answer should be very brief. 1.73. What is the ratio of the Imports(as % of merchandise exports) of 1965 in Spain to that in Switzerland?
Your response must be concise. 1.62. What is the ratio of the Imports(as % of merchandise exports) in 1962 in Spain to that in Thailand?
Give a very brief answer. 3.83. What is the ratio of the Imports(as % of merchandise exports) of 1963 in Spain to that in Thailand?
Your response must be concise. 3.01. What is the ratio of the Imports(as % of merchandise exports) in 1964 in Spain to that in Thailand?
Provide a short and direct response. 2.88. What is the ratio of the Imports(as % of merchandise exports) of 1965 in Spain to that in Thailand?
Provide a short and direct response. 3.19. What is the ratio of the Imports(as % of merchandise exports) in 1962 in Spain to that in Turkey?
Provide a succinct answer. 3.67. What is the ratio of the Imports(as % of merchandise exports) in 1963 in Spain to that in Turkey?
Keep it short and to the point. 3.74. What is the ratio of the Imports(as % of merchandise exports) in 1964 in Spain to that in Turkey?
Offer a terse response. 2.85. What is the ratio of the Imports(as % of merchandise exports) in 1965 in Spain to that in Turkey?
Make the answer very short. 2.42. What is the ratio of the Imports(as % of merchandise exports) of 1962 in Spain to that in United Kingdom?
Give a very brief answer. 0.69. What is the ratio of the Imports(as % of merchandise exports) in 1963 in Spain to that in United Kingdom?
Give a very brief answer. 0.63. What is the ratio of the Imports(as % of merchandise exports) of 1964 in Spain to that in United Kingdom?
Provide a succinct answer. 0.62. What is the ratio of the Imports(as % of merchandise exports) in 1965 in Spain to that in United Kingdom?
Offer a terse response. 0.63. What is the ratio of the Imports(as % of merchandise exports) in 1962 in Sweden to that in Switzerland?
Ensure brevity in your answer.  1.51. What is the ratio of the Imports(as % of merchandise exports) of 1963 in Sweden to that in Switzerland?
Offer a terse response. 1.58. What is the ratio of the Imports(as % of merchandise exports) of 1964 in Sweden to that in Switzerland?
Provide a short and direct response. 1.63. What is the ratio of the Imports(as % of merchandise exports) in 1965 in Sweden to that in Switzerland?
Your answer should be very brief. 1.75. What is the ratio of the Imports(as % of merchandise exports) in 1962 in Sweden to that in Thailand?
Provide a short and direct response. 3.39. What is the ratio of the Imports(as % of merchandise exports) in 1963 in Sweden to that in Thailand?
Offer a very short reply. 3.03. What is the ratio of the Imports(as % of merchandise exports) of 1964 in Sweden to that in Thailand?
Keep it short and to the point. 2.72. What is the ratio of the Imports(as % of merchandise exports) in 1965 in Sweden to that in Thailand?
Your answer should be compact. 3.44. What is the ratio of the Imports(as % of merchandise exports) of 1962 in Sweden to that in Turkey?
Provide a succinct answer. 3.25. What is the ratio of the Imports(as % of merchandise exports) in 1963 in Sweden to that in Turkey?
Keep it short and to the point. 3.76. What is the ratio of the Imports(as % of merchandise exports) in 1964 in Sweden to that in Turkey?
Offer a terse response. 2.69. What is the ratio of the Imports(as % of merchandise exports) in 1965 in Sweden to that in Turkey?
Provide a short and direct response. 2.61. What is the ratio of the Imports(as % of merchandise exports) of 1962 in Sweden to that in United Kingdom?
Ensure brevity in your answer.  0.61. What is the ratio of the Imports(as % of merchandise exports) in 1963 in Sweden to that in United Kingdom?
Offer a terse response. 0.64. What is the ratio of the Imports(as % of merchandise exports) of 1964 in Sweden to that in United Kingdom?
Make the answer very short. 0.59. What is the ratio of the Imports(as % of merchandise exports) of 1965 in Sweden to that in United Kingdom?
Provide a short and direct response. 0.68. What is the ratio of the Imports(as % of merchandise exports) in 1962 in Switzerland to that in Thailand?
Your answer should be very brief. 2.24. What is the ratio of the Imports(as % of merchandise exports) of 1963 in Switzerland to that in Thailand?
Provide a short and direct response. 1.92. What is the ratio of the Imports(as % of merchandise exports) in 1964 in Switzerland to that in Thailand?
Your response must be concise. 1.67. What is the ratio of the Imports(as % of merchandise exports) of 1965 in Switzerland to that in Thailand?
Give a very brief answer. 1.96. What is the ratio of the Imports(as % of merchandise exports) in 1962 in Switzerland to that in Turkey?
Keep it short and to the point. 2.15. What is the ratio of the Imports(as % of merchandise exports) of 1963 in Switzerland to that in Turkey?
Keep it short and to the point. 2.38. What is the ratio of the Imports(as % of merchandise exports) of 1964 in Switzerland to that in Turkey?
Provide a succinct answer. 1.65. What is the ratio of the Imports(as % of merchandise exports) in 1965 in Switzerland to that in Turkey?
Provide a succinct answer. 1.49. What is the ratio of the Imports(as % of merchandise exports) in 1962 in Switzerland to that in United Kingdom?
Keep it short and to the point. 0.4. What is the ratio of the Imports(as % of merchandise exports) of 1963 in Switzerland to that in United Kingdom?
Your answer should be compact. 0.4. What is the ratio of the Imports(as % of merchandise exports) of 1964 in Switzerland to that in United Kingdom?
Keep it short and to the point. 0.36. What is the ratio of the Imports(as % of merchandise exports) in 1965 in Switzerland to that in United Kingdom?
Offer a terse response. 0.39. What is the ratio of the Imports(as % of merchandise exports) of 1962 in Thailand to that in Turkey?
Give a very brief answer. 0.96. What is the ratio of the Imports(as % of merchandise exports) in 1963 in Thailand to that in Turkey?
Make the answer very short. 1.24. What is the ratio of the Imports(as % of merchandise exports) of 1964 in Thailand to that in Turkey?
Your response must be concise. 0.99. What is the ratio of the Imports(as % of merchandise exports) in 1965 in Thailand to that in Turkey?
Make the answer very short. 0.76. What is the ratio of the Imports(as % of merchandise exports) of 1962 in Thailand to that in United Kingdom?
Provide a succinct answer. 0.18. What is the ratio of the Imports(as % of merchandise exports) in 1963 in Thailand to that in United Kingdom?
Give a very brief answer. 0.21. What is the ratio of the Imports(as % of merchandise exports) in 1964 in Thailand to that in United Kingdom?
Provide a short and direct response. 0.22. What is the ratio of the Imports(as % of merchandise exports) in 1965 in Thailand to that in United Kingdom?
Keep it short and to the point. 0.2. What is the ratio of the Imports(as % of merchandise exports) in 1962 in Turkey to that in United Kingdom?
Offer a terse response. 0.19. What is the ratio of the Imports(as % of merchandise exports) in 1963 in Turkey to that in United Kingdom?
Keep it short and to the point. 0.17. What is the ratio of the Imports(as % of merchandise exports) of 1964 in Turkey to that in United Kingdom?
Give a very brief answer. 0.22. What is the ratio of the Imports(as % of merchandise exports) of 1965 in Turkey to that in United Kingdom?
Your answer should be compact. 0.26. What is the difference between the highest and the second highest Imports(as % of merchandise exports) of 1962?
Your answer should be compact. 2.88. What is the difference between the highest and the second highest Imports(as % of merchandise exports) of 1963?
Ensure brevity in your answer.  3.13. What is the difference between the highest and the second highest Imports(as % of merchandise exports) of 1964?
Make the answer very short. 3.8. What is the difference between the highest and the second highest Imports(as % of merchandise exports) of 1965?
Give a very brief answer. 3.44. What is the difference between the highest and the lowest Imports(as % of merchandise exports) of 1962?
Provide a short and direct response. 7.65. What is the difference between the highest and the lowest Imports(as % of merchandise exports) of 1963?
Make the answer very short. 7.19. What is the difference between the highest and the lowest Imports(as % of merchandise exports) of 1964?
Make the answer very short. 7.94. What is the difference between the highest and the lowest Imports(as % of merchandise exports) in 1965?
Make the answer very short. 8.62. 